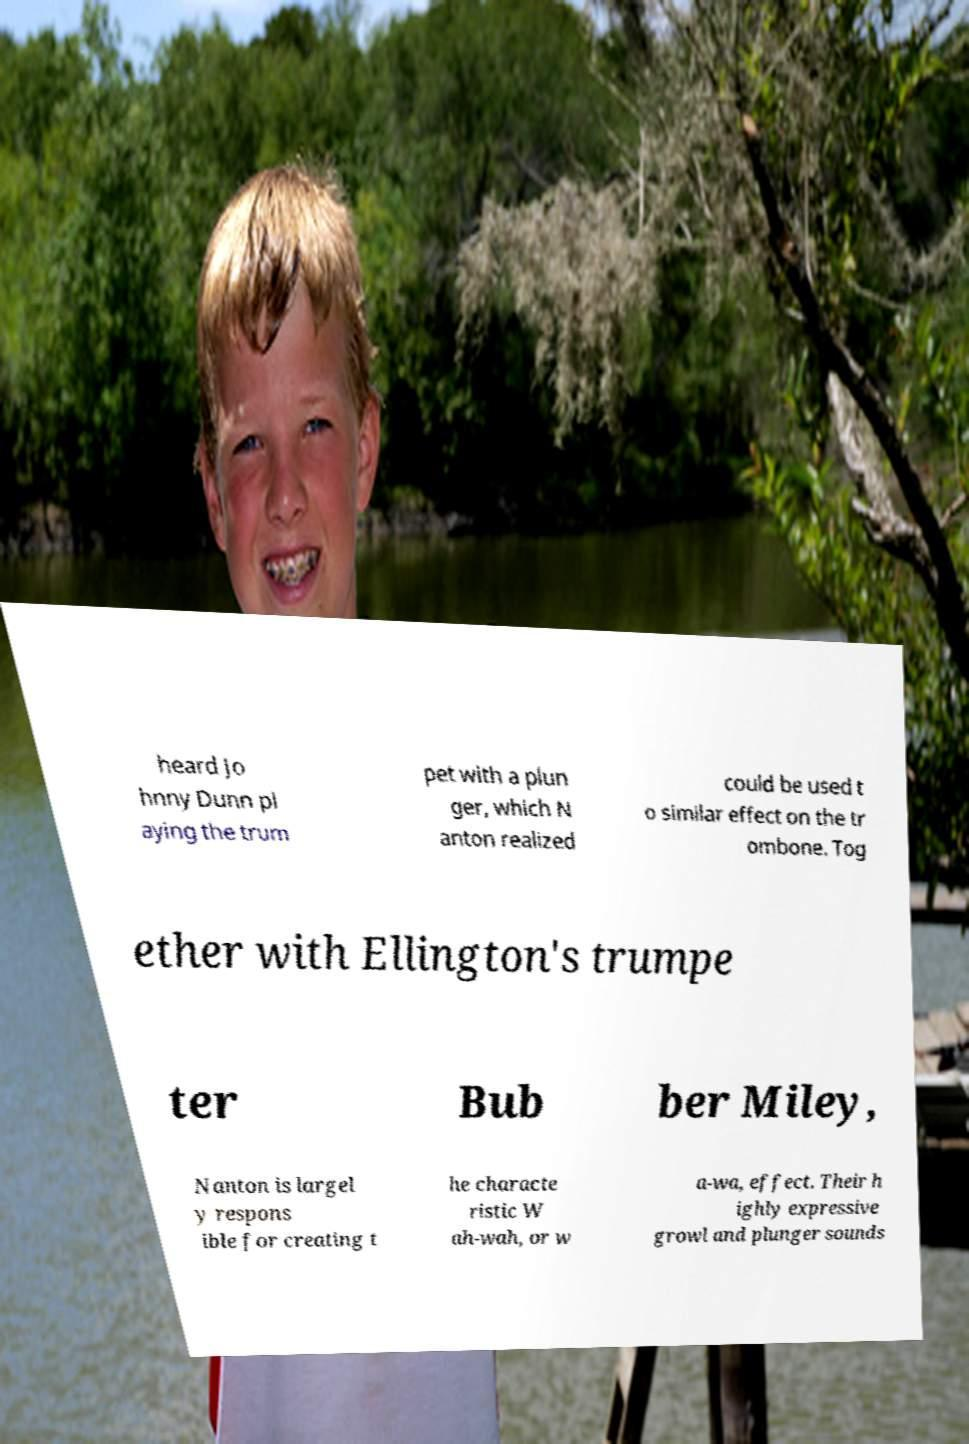Can you read and provide the text displayed in the image?This photo seems to have some interesting text. Can you extract and type it out for me? heard Jo hnny Dunn pl aying the trum pet with a plun ger, which N anton realized could be used t o similar effect on the tr ombone. Tog ether with Ellington's trumpe ter Bub ber Miley, Nanton is largel y respons ible for creating t he characte ristic W ah-wah, or w a-wa, effect. Their h ighly expressive growl and plunger sounds 